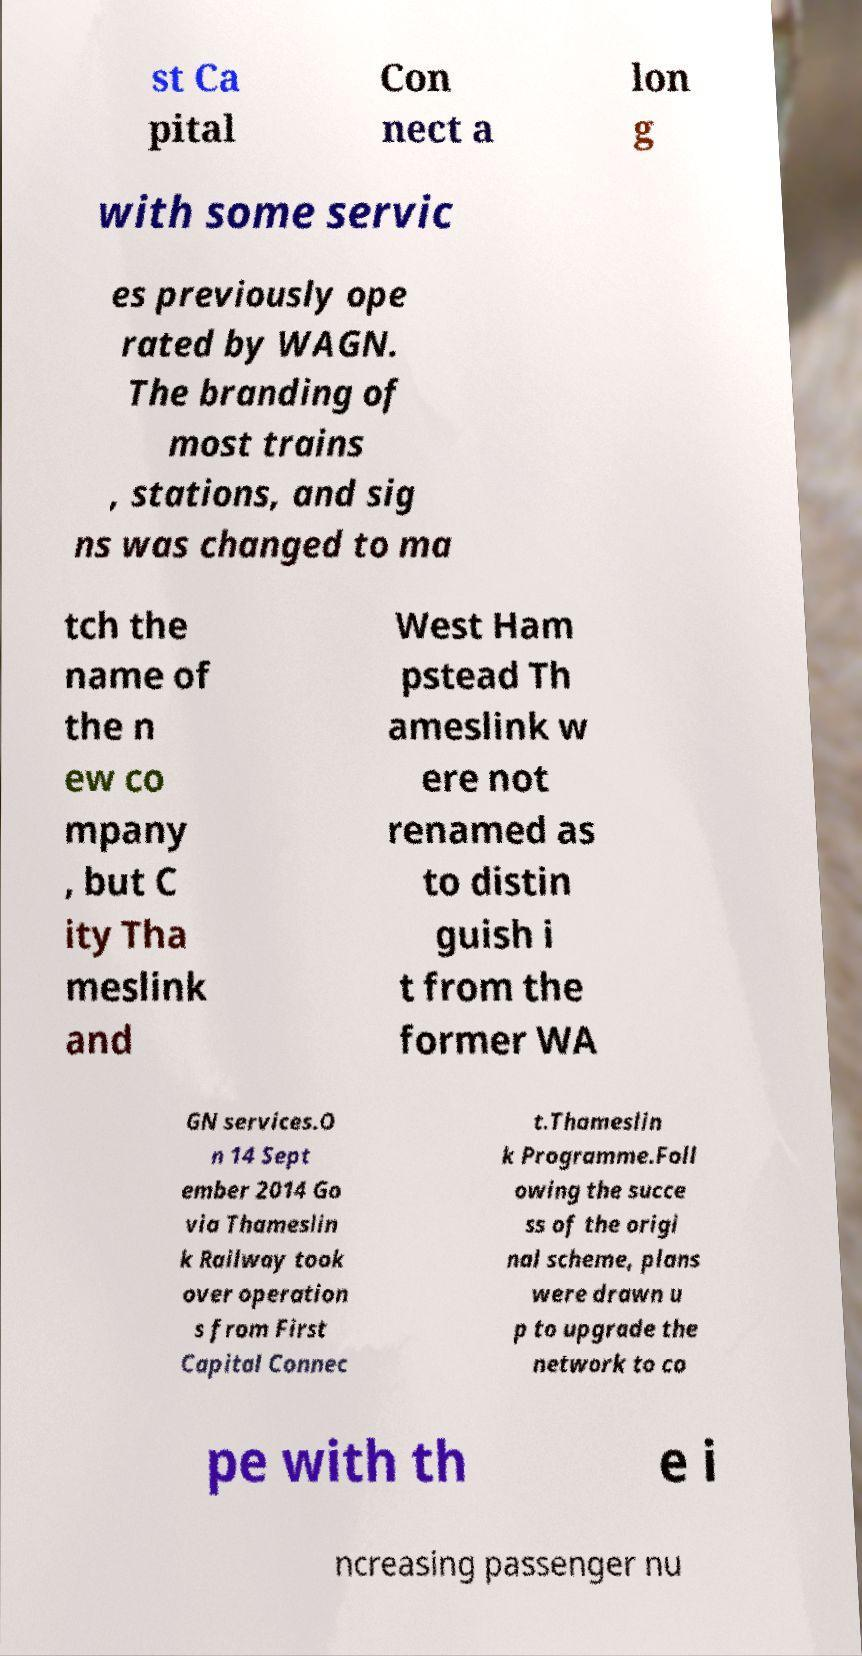Can you read and provide the text displayed in the image?This photo seems to have some interesting text. Can you extract and type it out for me? st Ca pital Con nect a lon g with some servic es previously ope rated by WAGN. The branding of most trains , stations, and sig ns was changed to ma tch the name of the n ew co mpany , but C ity Tha meslink and West Ham pstead Th ameslink w ere not renamed as to distin guish i t from the former WA GN services.O n 14 Sept ember 2014 Go via Thameslin k Railway took over operation s from First Capital Connec t.Thameslin k Programme.Foll owing the succe ss of the origi nal scheme, plans were drawn u p to upgrade the network to co pe with th e i ncreasing passenger nu 